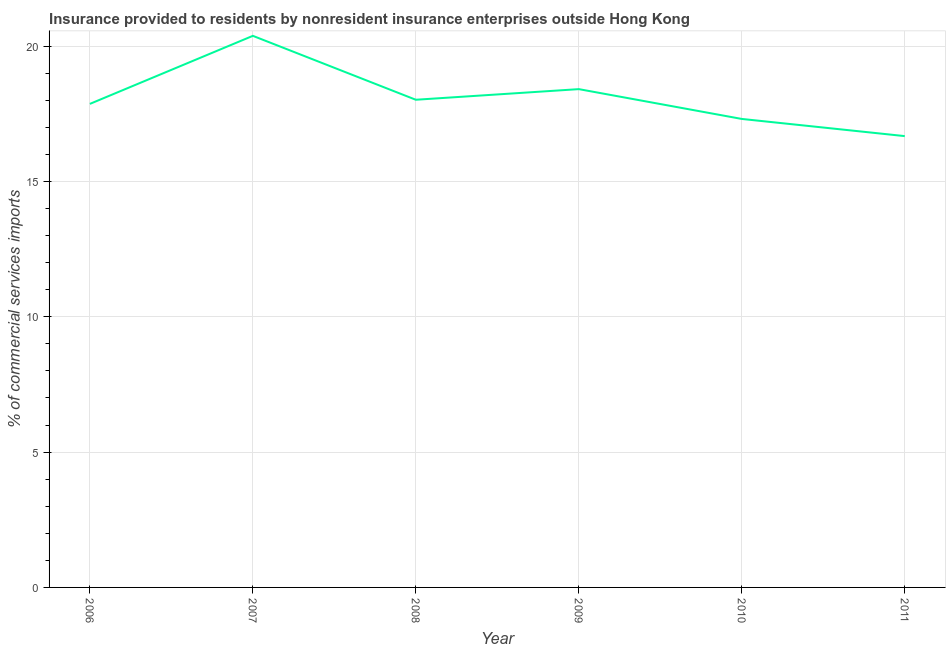What is the insurance provided by non-residents in 2011?
Offer a terse response. 16.68. Across all years, what is the maximum insurance provided by non-residents?
Ensure brevity in your answer.  20.38. Across all years, what is the minimum insurance provided by non-residents?
Give a very brief answer. 16.68. What is the sum of the insurance provided by non-residents?
Ensure brevity in your answer.  108.66. What is the difference between the insurance provided by non-residents in 2006 and 2008?
Give a very brief answer. -0.15. What is the average insurance provided by non-residents per year?
Your answer should be very brief. 18.11. What is the median insurance provided by non-residents?
Keep it short and to the point. 17.94. What is the ratio of the insurance provided by non-residents in 2008 to that in 2009?
Give a very brief answer. 0.98. Is the insurance provided by non-residents in 2009 less than that in 2011?
Give a very brief answer. No. Is the difference between the insurance provided by non-residents in 2007 and 2008 greater than the difference between any two years?
Provide a short and direct response. No. What is the difference between the highest and the second highest insurance provided by non-residents?
Make the answer very short. 1.97. What is the difference between the highest and the lowest insurance provided by non-residents?
Give a very brief answer. 3.7. How many lines are there?
Give a very brief answer. 1. What is the difference between two consecutive major ticks on the Y-axis?
Offer a terse response. 5. Are the values on the major ticks of Y-axis written in scientific E-notation?
Your answer should be very brief. No. Does the graph contain grids?
Provide a short and direct response. Yes. What is the title of the graph?
Your answer should be compact. Insurance provided to residents by nonresident insurance enterprises outside Hong Kong. What is the label or title of the X-axis?
Give a very brief answer. Year. What is the label or title of the Y-axis?
Your response must be concise. % of commercial services imports. What is the % of commercial services imports of 2006?
Your answer should be very brief. 17.87. What is the % of commercial services imports of 2007?
Provide a succinct answer. 20.38. What is the % of commercial services imports of 2008?
Your answer should be very brief. 18.02. What is the % of commercial services imports of 2009?
Make the answer very short. 18.41. What is the % of commercial services imports of 2010?
Offer a terse response. 17.31. What is the % of commercial services imports in 2011?
Ensure brevity in your answer.  16.68. What is the difference between the % of commercial services imports in 2006 and 2007?
Offer a terse response. -2.51. What is the difference between the % of commercial services imports in 2006 and 2008?
Your answer should be compact. -0.15. What is the difference between the % of commercial services imports in 2006 and 2009?
Make the answer very short. -0.55. What is the difference between the % of commercial services imports in 2006 and 2010?
Provide a succinct answer. 0.56. What is the difference between the % of commercial services imports in 2006 and 2011?
Your answer should be very brief. 1.19. What is the difference between the % of commercial services imports in 2007 and 2008?
Ensure brevity in your answer.  2.36. What is the difference between the % of commercial services imports in 2007 and 2009?
Your response must be concise. 1.97. What is the difference between the % of commercial services imports in 2007 and 2010?
Your answer should be compact. 3.07. What is the difference between the % of commercial services imports in 2007 and 2011?
Keep it short and to the point. 3.7. What is the difference between the % of commercial services imports in 2008 and 2009?
Your answer should be compact. -0.39. What is the difference between the % of commercial services imports in 2008 and 2010?
Provide a short and direct response. 0.71. What is the difference between the % of commercial services imports in 2008 and 2011?
Keep it short and to the point. 1.34. What is the difference between the % of commercial services imports in 2009 and 2010?
Offer a very short reply. 1.1. What is the difference between the % of commercial services imports in 2009 and 2011?
Your response must be concise. 1.74. What is the difference between the % of commercial services imports in 2010 and 2011?
Offer a very short reply. 0.63. What is the ratio of the % of commercial services imports in 2006 to that in 2007?
Provide a succinct answer. 0.88. What is the ratio of the % of commercial services imports in 2006 to that in 2008?
Provide a short and direct response. 0.99. What is the ratio of the % of commercial services imports in 2006 to that in 2010?
Ensure brevity in your answer.  1.03. What is the ratio of the % of commercial services imports in 2006 to that in 2011?
Keep it short and to the point. 1.07. What is the ratio of the % of commercial services imports in 2007 to that in 2008?
Your response must be concise. 1.13. What is the ratio of the % of commercial services imports in 2007 to that in 2009?
Provide a short and direct response. 1.11. What is the ratio of the % of commercial services imports in 2007 to that in 2010?
Give a very brief answer. 1.18. What is the ratio of the % of commercial services imports in 2007 to that in 2011?
Your answer should be compact. 1.22. What is the ratio of the % of commercial services imports in 2008 to that in 2010?
Offer a very short reply. 1.04. What is the ratio of the % of commercial services imports in 2008 to that in 2011?
Offer a terse response. 1.08. What is the ratio of the % of commercial services imports in 2009 to that in 2010?
Provide a short and direct response. 1.06. What is the ratio of the % of commercial services imports in 2009 to that in 2011?
Provide a succinct answer. 1.1. What is the ratio of the % of commercial services imports in 2010 to that in 2011?
Provide a short and direct response. 1.04. 